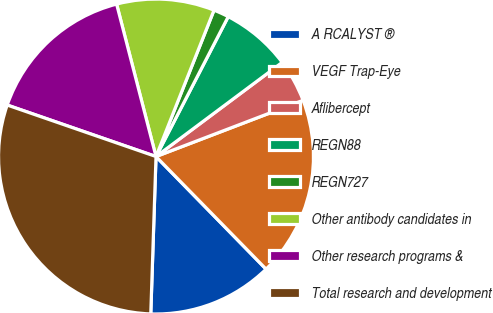<chart> <loc_0><loc_0><loc_500><loc_500><pie_chart><fcel>A RCALYST ®<fcel>VEGF Trap-Eye<fcel>Aflibercept<fcel>REGN88<fcel>REGN727<fcel>Other antibody candidates in<fcel>Other research programs &<fcel>Total research and development<nl><fcel>12.85%<fcel>18.49%<fcel>4.39%<fcel>7.21%<fcel>1.58%<fcel>10.03%<fcel>15.67%<fcel>29.77%<nl></chart> 